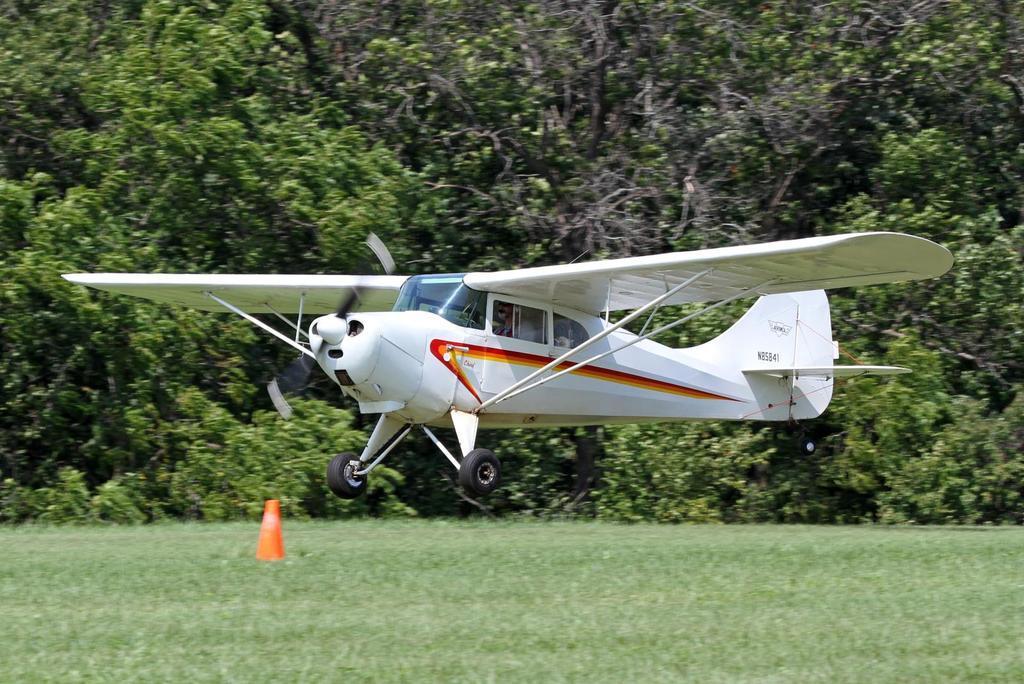How would you summarize this image in a sentence or two? In this image, we can see a person is riding an aircraft in the air. At the bottom, we can see grass and cone. Background there are so many trees and plants. 